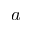<formula> <loc_0><loc_0><loc_500><loc_500>a</formula> 